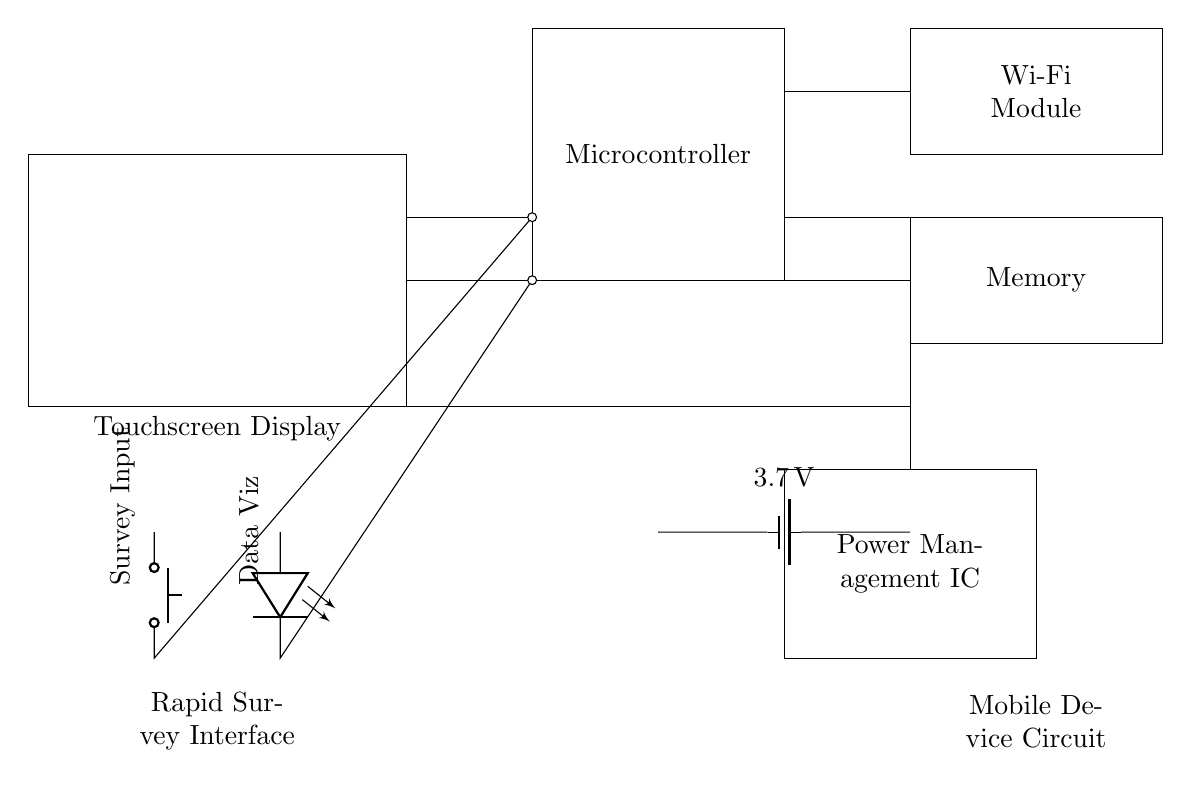What is the main power source? The main power source is the battery, which supplies the circuit with 3.7 volts.
Answer: Battery What component manages the power distribution? The Power Management IC is responsible for managing the power distribution throughout the circuit to various components.
Answer: Power Management IC How many components are interconnected with the microcontroller? There are three components interconnected with the microcontroller: Power Management IC, Wi-Fi module, and Memory.
Answer: Three What is the purpose of the push button in this circuit? The push button serves as the survey input, allowing users to initiate a survey response when pressed.
Answer: Survey Input What is the function of the LED in this circuit? The LED is used for data visualization, indicating the status of the survey input process or the data being processed.
Answer: Data Visualization What voltage does the battery provide? The battery provides a voltage of 3.7 volts to the circuit, which is crucial for powering the components.
Answer: 3.7 volts Which module allows the device to connect to the internet? The Wi-Fi module enables the device to connect to the internet, facilitating data transmission and reception for survey input.
Answer: Wi-Fi Module 